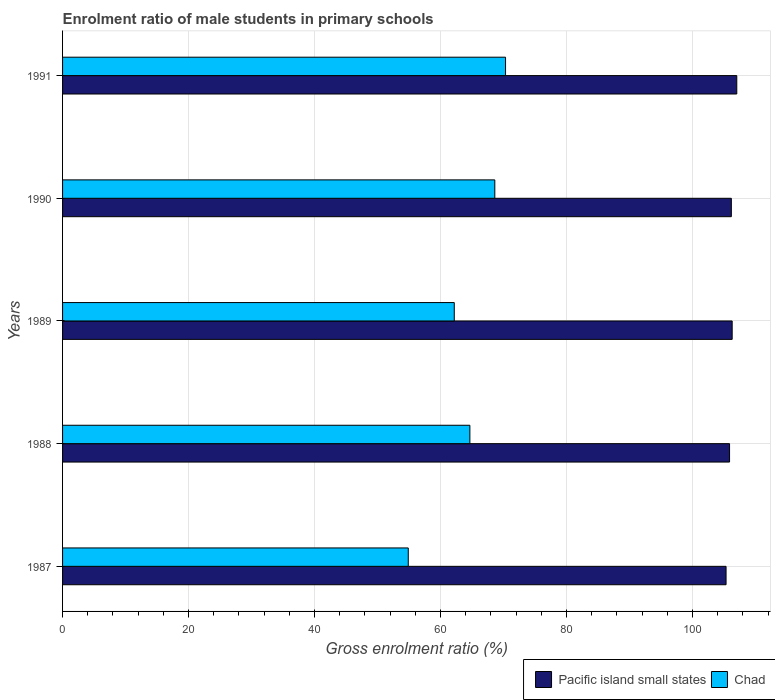Are the number of bars per tick equal to the number of legend labels?
Your answer should be very brief. Yes. How many bars are there on the 2nd tick from the bottom?
Offer a terse response. 2. What is the label of the 2nd group of bars from the top?
Your response must be concise. 1990. In how many cases, is the number of bars for a given year not equal to the number of legend labels?
Your response must be concise. 0. What is the enrolment ratio of male students in primary schools in Pacific island small states in 1988?
Your answer should be very brief. 105.88. Across all years, what is the maximum enrolment ratio of male students in primary schools in Chad?
Ensure brevity in your answer.  70.32. Across all years, what is the minimum enrolment ratio of male students in primary schools in Chad?
Your answer should be compact. 54.88. In which year was the enrolment ratio of male students in primary schools in Pacific island small states minimum?
Your response must be concise. 1987. What is the total enrolment ratio of male students in primary schools in Chad in the graph?
Give a very brief answer. 320.65. What is the difference between the enrolment ratio of male students in primary schools in Pacific island small states in 1988 and that in 1989?
Your response must be concise. -0.41. What is the difference between the enrolment ratio of male students in primary schools in Chad in 1987 and the enrolment ratio of male students in primary schools in Pacific island small states in 1989?
Your answer should be very brief. -51.42. What is the average enrolment ratio of male students in primary schools in Chad per year?
Your answer should be very brief. 64.13. In the year 1987, what is the difference between the enrolment ratio of male students in primary schools in Chad and enrolment ratio of male students in primary schools in Pacific island small states?
Ensure brevity in your answer.  -50.45. In how many years, is the enrolment ratio of male students in primary schools in Chad greater than 100 %?
Your answer should be very brief. 0. What is the ratio of the enrolment ratio of male students in primary schools in Pacific island small states in 1988 to that in 1990?
Keep it short and to the point. 1. Is the difference between the enrolment ratio of male students in primary schools in Chad in 1987 and 1989 greater than the difference between the enrolment ratio of male students in primary schools in Pacific island small states in 1987 and 1989?
Your response must be concise. No. What is the difference between the highest and the second highest enrolment ratio of male students in primary schools in Pacific island small states?
Give a very brief answer. 0.73. What is the difference between the highest and the lowest enrolment ratio of male students in primary schools in Pacific island small states?
Ensure brevity in your answer.  1.7. Is the sum of the enrolment ratio of male students in primary schools in Pacific island small states in 1987 and 1989 greater than the maximum enrolment ratio of male students in primary schools in Chad across all years?
Your answer should be compact. Yes. What does the 1st bar from the top in 1987 represents?
Your answer should be compact. Chad. What does the 2nd bar from the bottom in 1990 represents?
Provide a succinct answer. Chad. Are all the bars in the graph horizontal?
Make the answer very short. Yes. What is the difference between two consecutive major ticks on the X-axis?
Provide a short and direct response. 20. Does the graph contain any zero values?
Provide a short and direct response. No. Does the graph contain grids?
Ensure brevity in your answer.  Yes. How are the legend labels stacked?
Your response must be concise. Horizontal. What is the title of the graph?
Your answer should be very brief. Enrolment ratio of male students in primary schools. What is the label or title of the X-axis?
Keep it short and to the point. Gross enrolment ratio (%). What is the Gross enrolment ratio (%) in Pacific island small states in 1987?
Your answer should be very brief. 105.33. What is the Gross enrolment ratio (%) of Chad in 1987?
Your response must be concise. 54.88. What is the Gross enrolment ratio (%) of Pacific island small states in 1988?
Keep it short and to the point. 105.88. What is the Gross enrolment ratio (%) in Chad in 1988?
Your response must be concise. 64.66. What is the Gross enrolment ratio (%) in Pacific island small states in 1989?
Your answer should be very brief. 106.29. What is the Gross enrolment ratio (%) of Chad in 1989?
Provide a short and direct response. 62.18. What is the Gross enrolment ratio (%) of Pacific island small states in 1990?
Your answer should be compact. 106.16. What is the Gross enrolment ratio (%) in Chad in 1990?
Provide a short and direct response. 68.61. What is the Gross enrolment ratio (%) of Pacific island small states in 1991?
Your answer should be very brief. 107.03. What is the Gross enrolment ratio (%) in Chad in 1991?
Offer a terse response. 70.32. Across all years, what is the maximum Gross enrolment ratio (%) of Pacific island small states?
Offer a terse response. 107.03. Across all years, what is the maximum Gross enrolment ratio (%) of Chad?
Your answer should be very brief. 70.32. Across all years, what is the minimum Gross enrolment ratio (%) in Pacific island small states?
Ensure brevity in your answer.  105.33. Across all years, what is the minimum Gross enrolment ratio (%) in Chad?
Offer a very short reply. 54.88. What is the total Gross enrolment ratio (%) of Pacific island small states in the graph?
Keep it short and to the point. 530.69. What is the total Gross enrolment ratio (%) of Chad in the graph?
Make the answer very short. 320.65. What is the difference between the Gross enrolment ratio (%) in Pacific island small states in 1987 and that in 1988?
Keep it short and to the point. -0.56. What is the difference between the Gross enrolment ratio (%) of Chad in 1987 and that in 1988?
Provide a succinct answer. -9.78. What is the difference between the Gross enrolment ratio (%) of Pacific island small states in 1987 and that in 1989?
Give a very brief answer. -0.97. What is the difference between the Gross enrolment ratio (%) in Chad in 1987 and that in 1989?
Keep it short and to the point. -7.3. What is the difference between the Gross enrolment ratio (%) in Pacific island small states in 1987 and that in 1990?
Provide a short and direct response. -0.84. What is the difference between the Gross enrolment ratio (%) in Chad in 1987 and that in 1990?
Offer a terse response. -13.74. What is the difference between the Gross enrolment ratio (%) in Pacific island small states in 1987 and that in 1991?
Make the answer very short. -1.7. What is the difference between the Gross enrolment ratio (%) of Chad in 1987 and that in 1991?
Give a very brief answer. -15.44. What is the difference between the Gross enrolment ratio (%) in Pacific island small states in 1988 and that in 1989?
Offer a very short reply. -0.41. What is the difference between the Gross enrolment ratio (%) in Chad in 1988 and that in 1989?
Ensure brevity in your answer.  2.48. What is the difference between the Gross enrolment ratio (%) in Pacific island small states in 1988 and that in 1990?
Provide a succinct answer. -0.28. What is the difference between the Gross enrolment ratio (%) of Chad in 1988 and that in 1990?
Give a very brief answer. -3.96. What is the difference between the Gross enrolment ratio (%) in Pacific island small states in 1988 and that in 1991?
Offer a very short reply. -1.15. What is the difference between the Gross enrolment ratio (%) of Chad in 1988 and that in 1991?
Your response must be concise. -5.66. What is the difference between the Gross enrolment ratio (%) in Pacific island small states in 1989 and that in 1990?
Give a very brief answer. 0.13. What is the difference between the Gross enrolment ratio (%) of Chad in 1989 and that in 1990?
Offer a very short reply. -6.44. What is the difference between the Gross enrolment ratio (%) of Pacific island small states in 1989 and that in 1991?
Give a very brief answer. -0.73. What is the difference between the Gross enrolment ratio (%) in Chad in 1989 and that in 1991?
Offer a terse response. -8.14. What is the difference between the Gross enrolment ratio (%) in Pacific island small states in 1990 and that in 1991?
Provide a short and direct response. -0.86. What is the difference between the Gross enrolment ratio (%) in Chad in 1990 and that in 1991?
Make the answer very short. -1.71. What is the difference between the Gross enrolment ratio (%) of Pacific island small states in 1987 and the Gross enrolment ratio (%) of Chad in 1988?
Provide a succinct answer. 40.67. What is the difference between the Gross enrolment ratio (%) in Pacific island small states in 1987 and the Gross enrolment ratio (%) in Chad in 1989?
Provide a short and direct response. 43.15. What is the difference between the Gross enrolment ratio (%) of Pacific island small states in 1987 and the Gross enrolment ratio (%) of Chad in 1990?
Give a very brief answer. 36.71. What is the difference between the Gross enrolment ratio (%) of Pacific island small states in 1987 and the Gross enrolment ratio (%) of Chad in 1991?
Offer a very short reply. 35. What is the difference between the Gross enrolment ratio (%) in Pacific island small states in 1988 and the Gross enrolment ratio (%) in Chad in 1989?
Your answer should be compact. 43.7. What is the difference between the Gross enrolment ratio (%) in Pacific island small states in 1988 and the Gross enrolment ratio (%) in Chad in 1990?
Make the answer very short. 37.27. What is the difference between the Gross enrolment ratio (%) in Pacific island small states in 1988 and the Gross enrolment ratio (%) in Chad in 1991?
Ensure brevity in your answer.  35.56. What is the difference between the Gross enrolment ratio (%) of Pacific island small states in 1989 and the Gross enrolment ratio (%) of Chad in 1990?
Provide a succinct answer. 37.68. What is the difference between the Gross enrolment ratio (%) in Pacific island small states in 1989 and the Gross enrolment ratio (%) in Chad in 1991?
Your response must be concise. 35.97. What is the difference between the Gross enrolment ratio (%) in Pacific island small states in 1990 and the Gross enrolment ratio (%) in Chad in 1991?
Your answer should be compact. 35.84. What is the average Gross enrolment ratio (%) in Pacific island small states per year?
Your answer should be compact. 106.14. What is the average Gross enrolment ratio (%) of Chad per year?
Offer a very short reply. 64.13. In the year 1987, what is the difference between the Gross enrolment ratio (%) of Pacific island small states and Gross enrolment ratio (%) of Chad?
Your answer should be very brief. 50.45. In the year 1988, what is the difference between the Gross enrolment ratio (%) in Pacific island small states and Gross enrolment ratio (%) in Chad?
Provide a succinct answer. 41.22. In the year 1989, what is the difference between the Gross enrolment ratio (%) of Pacific island small states and Gross enrolment ratio (%) of Chad?
Keep it short and to the point. 44.11. In the year 1990, what is the difference between the Gross enrolment ratio (%) of Pacific island small states and Gross enrolment ratio (%) of Chad?
Your response must be concise. 37.55. In the year 1991, what is the difference between the Gross enrolment ratio (%) in Pacific island small states and Gross enrolment ratio (%) in Chad?
Offer a very short reply. 36.71. What is the ratio of the Gross enrolment ratio (%) of Chad in 1987 to that in 1988?
Your answer should be very brief. 0.85. What is the ratio of the Gross enrolment ratio (%) in Pacific island small states in 1987 to that in 1989?
Give a very brief answer. 0.99. What is the ratio of the Gross enrolment ratio (%) of Chad in 1987 to that in 1989?
Provide a short and direct response. 0.88. What is the ratio of the Gross enrolment ratio (%) of Chad in 1987 to that in 1990?
Your answer should be compact. 0.8. What is the ratio of the Gross enrolment ratio (%) of Pacific island small states in 1987 to that in 1991?
Make the answer very short. 0.98. What is the ratio of the Gross enrolment ratio (%) of Chad in 1987 to that in 1991?
Make the answer very short. 0.78. What is the ratio of the Gross enrolment ratio (%) of Pacific island small states in 1988 to that in 1989?
Offer a very short reply. 1. What is the ratio of the Gross enrolment ratio (%) of Chad in 1988 to that in 1989?
Provide a short and direct response. 1.04. What is the ratio of the Gross enrolment ratio (%) in Pacific island small states in 1988 to that in 1990?
Keep it short and to the point. 1. What is the ratio of the Gross enrolment ratio (%) of Chad in 1988 to that in 1990?
Your response must be concise. 0.94. What is the ratio of the Gross enrolment ratio (%) in Pacific island small states in 1988 to that in 1991?
Your response must be concise. 0.99. What is the ratio of the Gross enrolment ratio (%) of Chad in 1988 to that in 1991?
Your response must be concise. 0.92. What is the ratio of the Gross enrolment ratio (%) of Chad in 1989 to that in 1990?
Your answer should be very brief. 0.91. What is the ratio of the Gross enrolment ratio (%) in Chad in 1989 to that in 1991?
Ensure brevity in your answer.  0.88. What is the ratio of the Gross enrolment ratio (%) of Chad in 1990 to that in 1991?
Make the answer very short. 0.98. What is the difference between the highest and the second highest Gross enrolment ratio (%) in Pacific island small states?
Your answer should be very brief. 0.73. What is the difference between the highest and the second highest Gross enrolment ratio (%) in Chad?
Your response must be concise. 1.71. What is the difference between the highest and the lowest Gross enrolment ratio (%) of Pacific island small states?
Keep it short and to the point. 1.7. What is the difference between the highest and the lowest Gross enrolment ratio (%) of Chad?
Offer a very short reply. 15.44. 